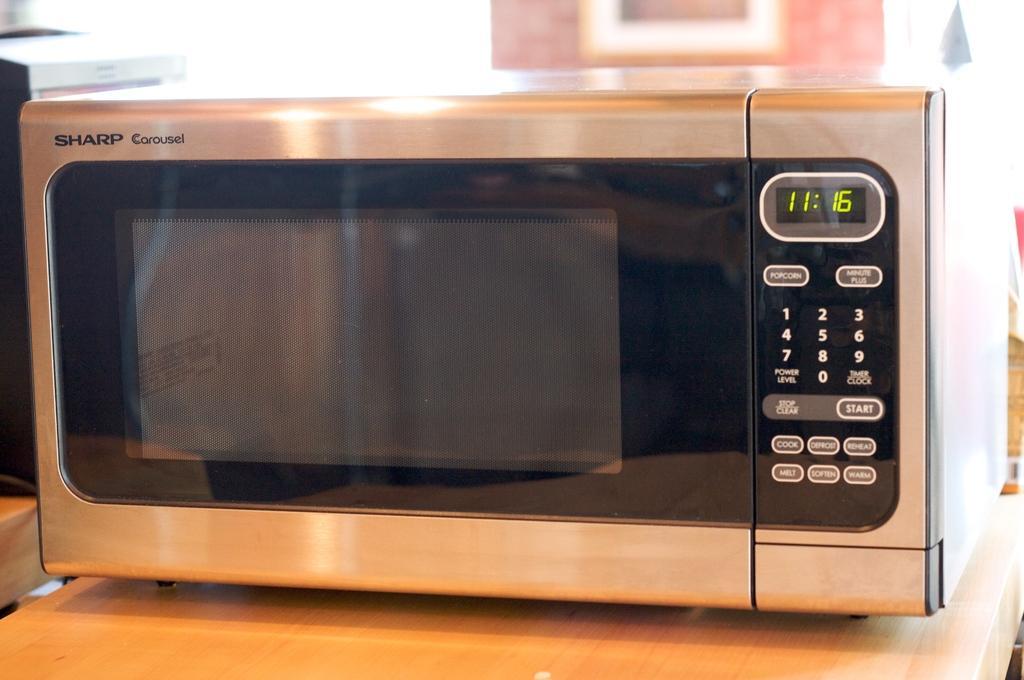Could you give a brief overview of what you see in this image? We can see oven on the wooden surface. In the background it is blur. 